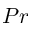<formula> <loc_0><loc_0><loc_500><loc_500>P r</formula> 